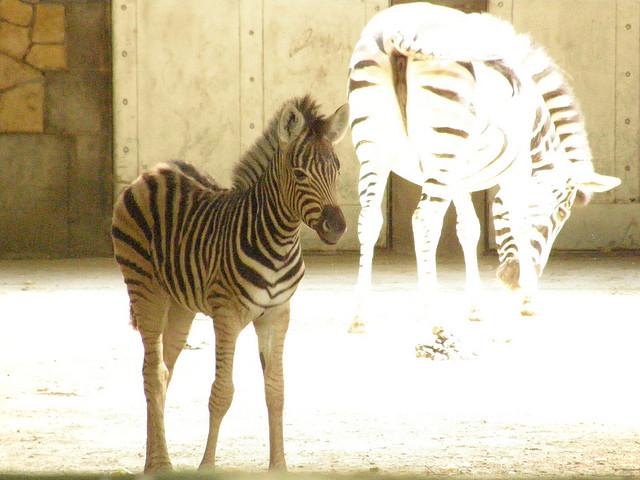How many zebras?
Quick response, please. 2. What color are these animals?
Answer briefly. Black and white. Is there an adolescent zebra in the foreground?
Keep it brief. Yes. 